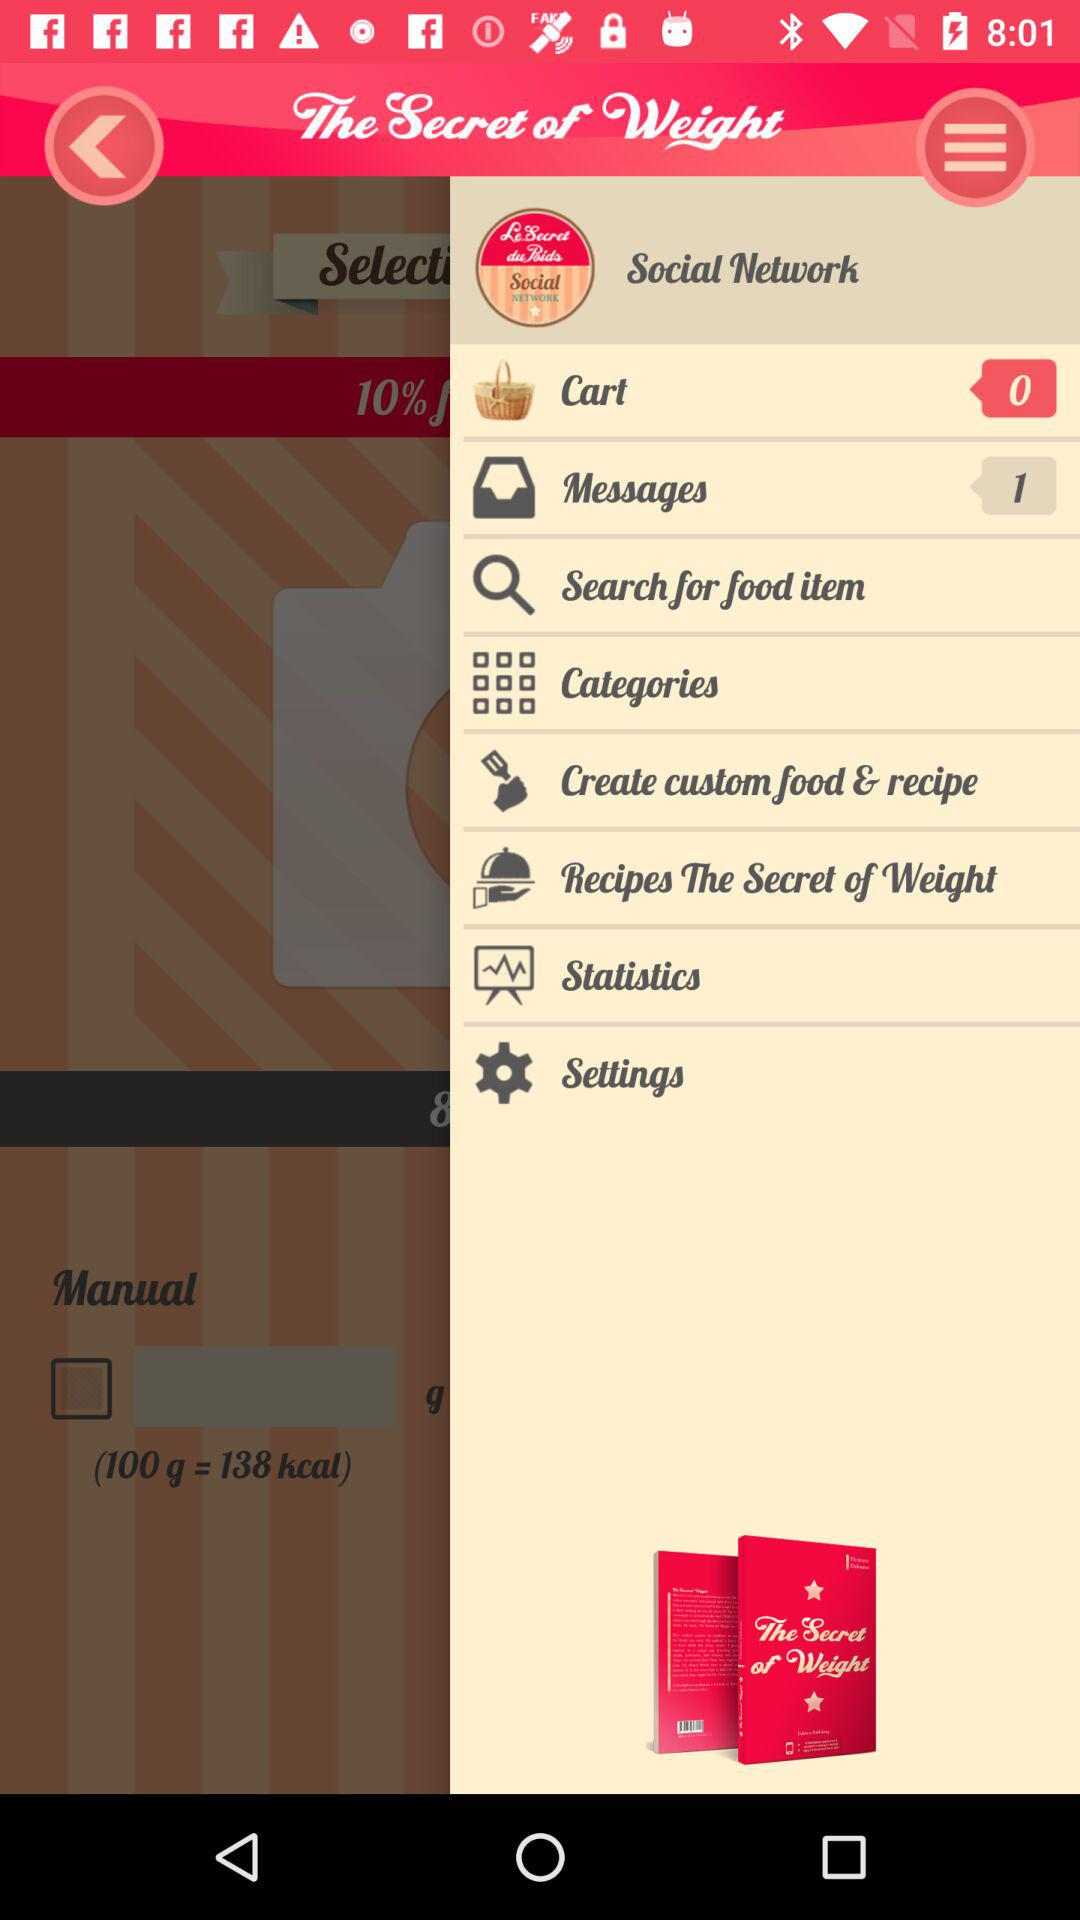100g is equal to how many kcal? It is equal to 138 kcal. 